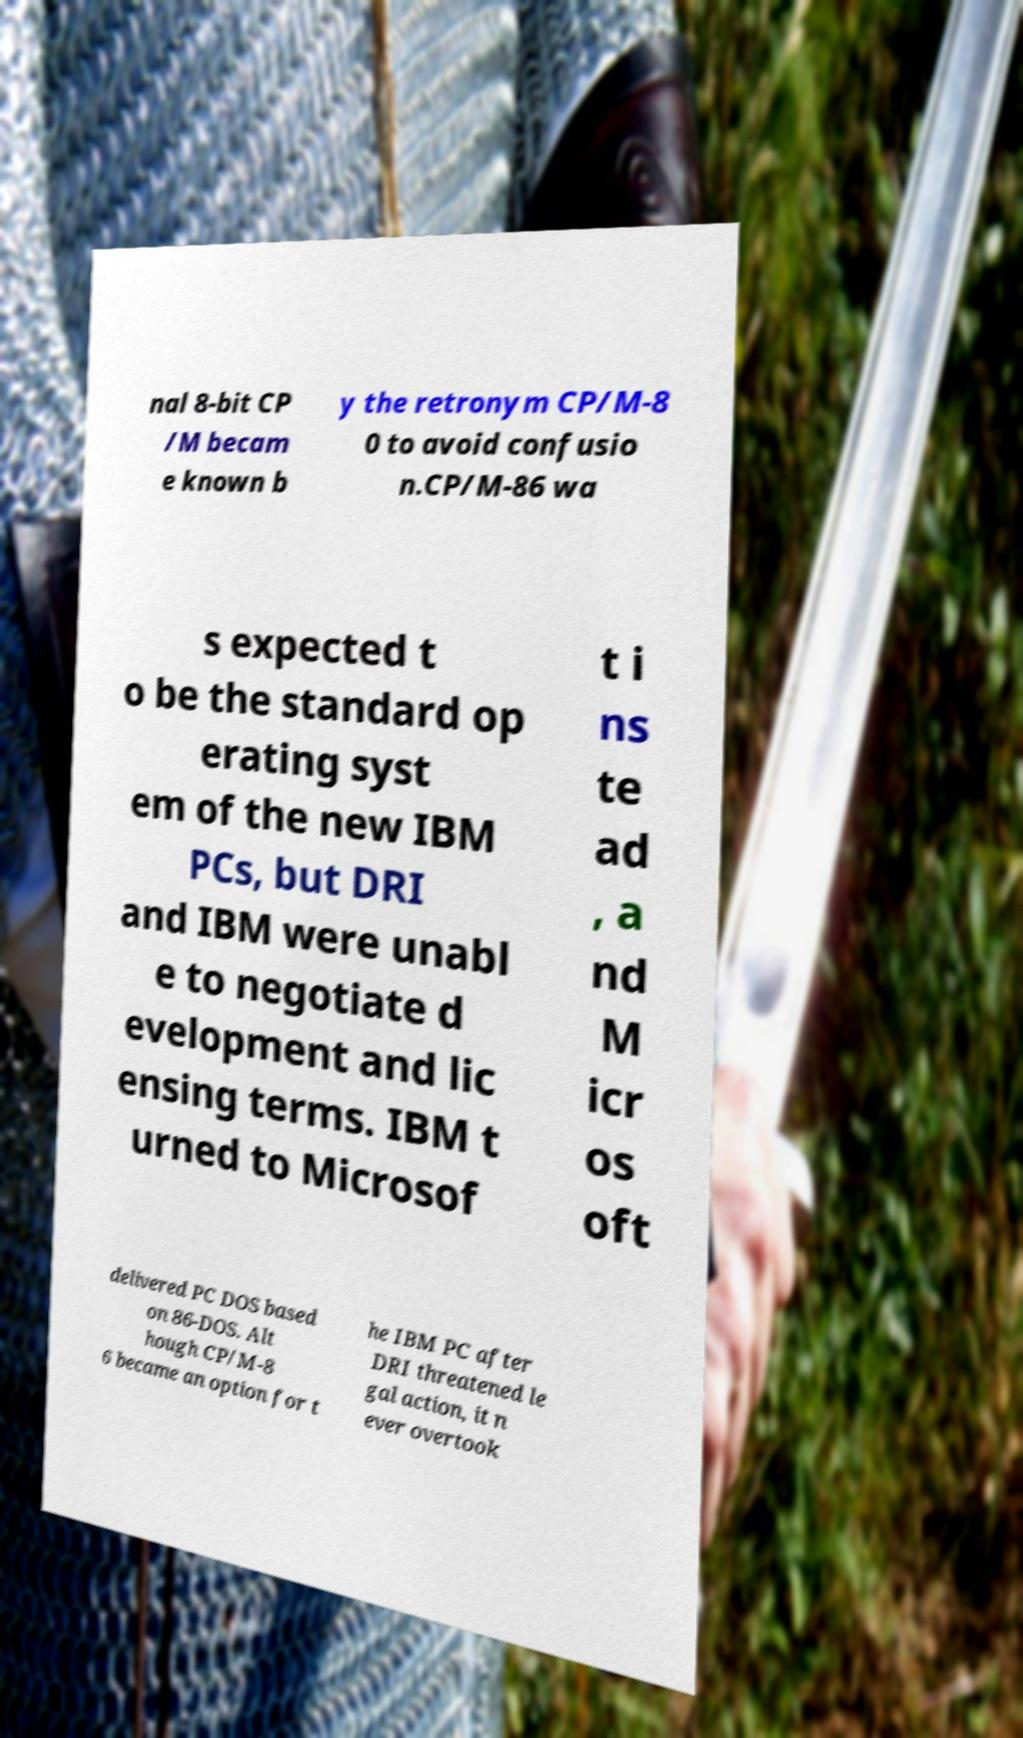What messages or text are displayed in this image? I need them in a readable, typed format. nal 8-bit CP /M becam e known b y the retronym CP/M-8 0 to avoid confusio n.CP/M-86 wa s expected t o be the standard op erating syst em of the new IBM PCs, but DRI and IBM were unabl e to negotiate d evelopment and lic ensing terms. IBM t urned to Microsof t i ns te ad , a nd M icr os oft delivered PC DOS based on 86-DOS. Alt hough CP/M-8 6 became an option for t he IBM PC after DRI threatened le gal action, it n ever overtook 